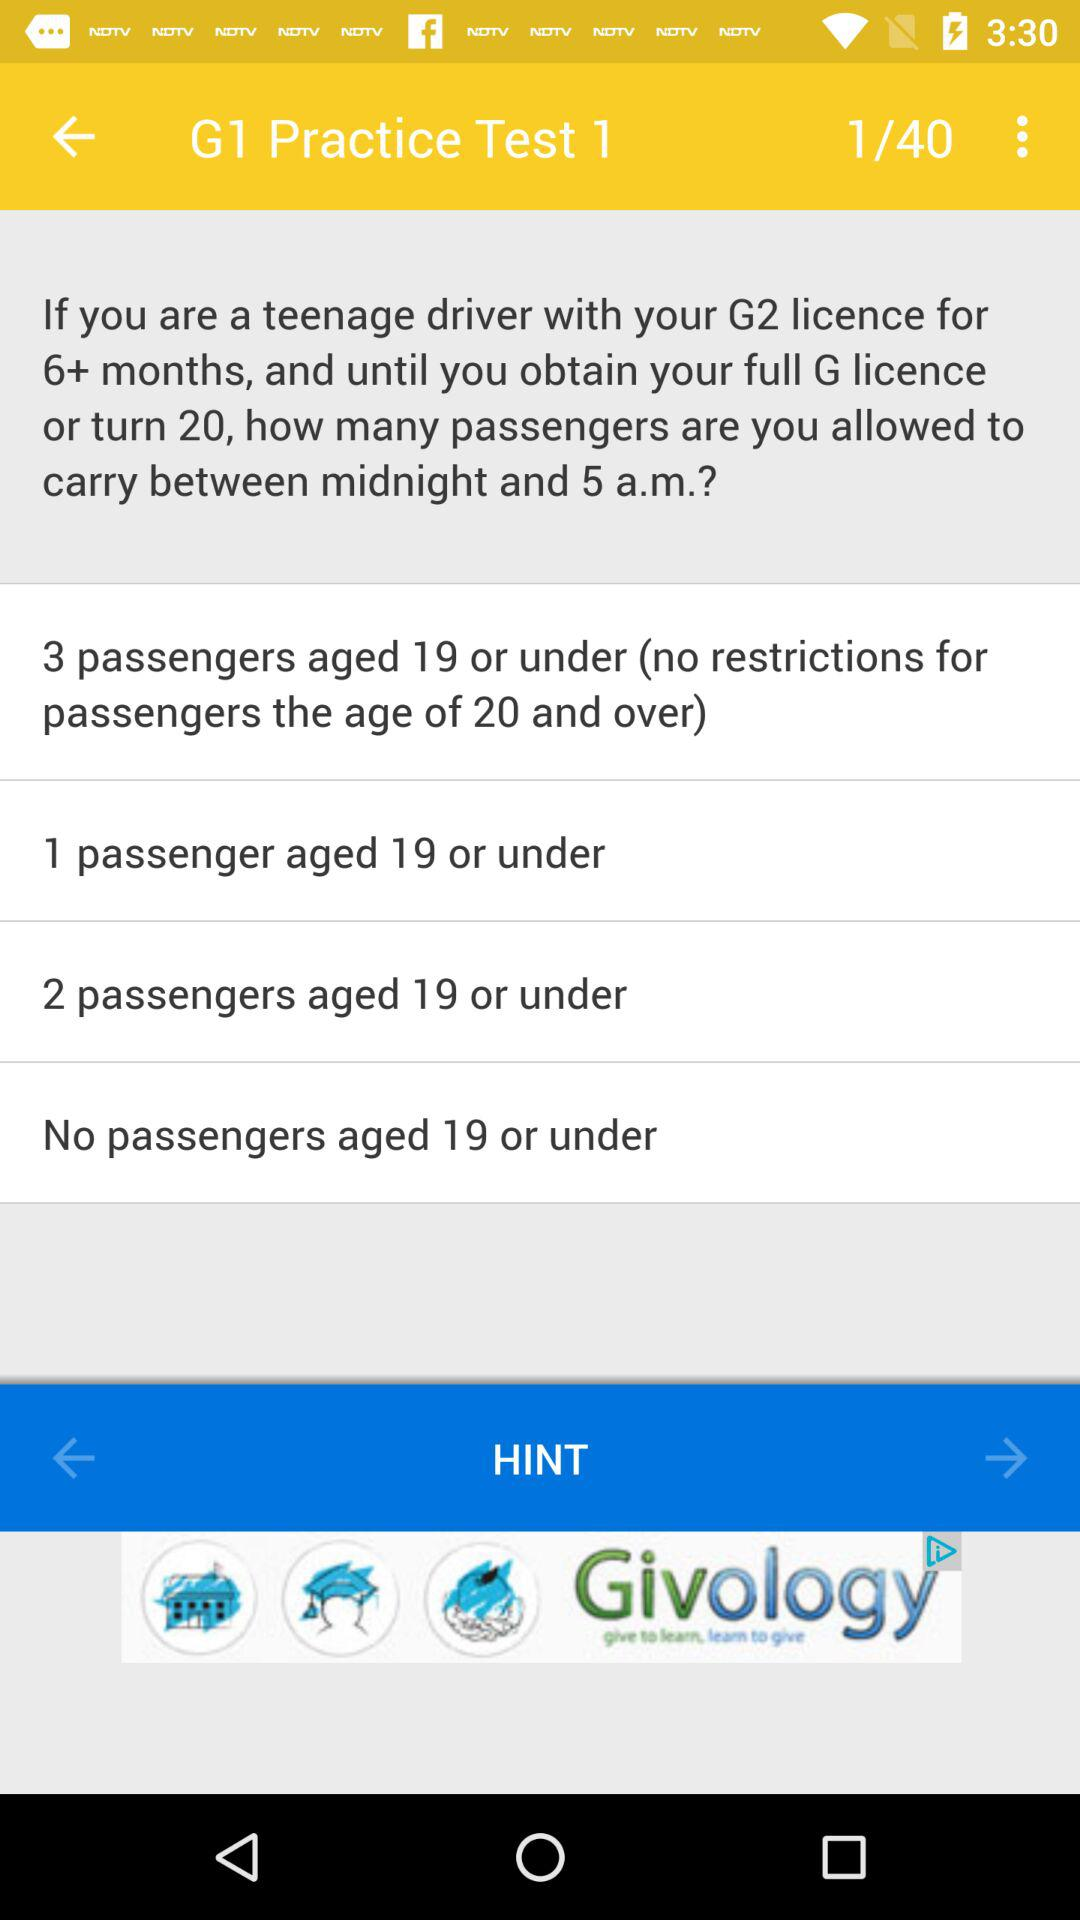How many options are there for the number of passengers under 19 that a teenage driver with a G2 licence can carry between midnight and 5 a.m.?
Answer the question using a single word or phrase. 4 